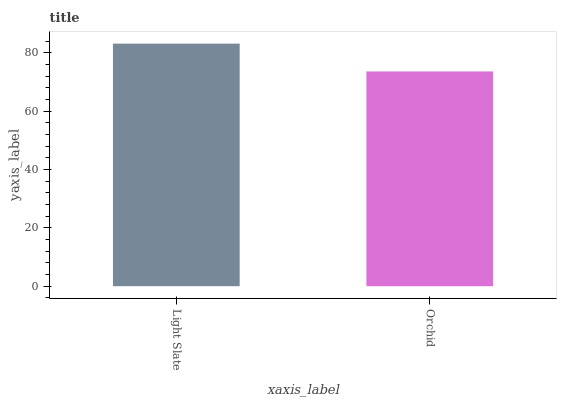Is Orchid the minimum?
Answer yes or no. Yes. Is Light Slate the maximum?
Answer yes or no. Yes. Is Orchid the maximum?
Answer yes or no. No. Is Light Slate greater than Orchid?
Answer yes or no. Yes. Is Orchid less than Light Slate?
Answer yes or no. Yes. Is Orchid greater than Light Slate?
Answer yes or no. No. Is Light Slate less than Orchid?
Answer yes or no. No. Is Light Slate the high median?
Answer yes or no. Yes. Is Orchid the low median?
Answer yes or no. Yes. Is Orchid the high median?
Answer yes or no. No. Is Light Slate the low median?
Answer yes or no. No. 